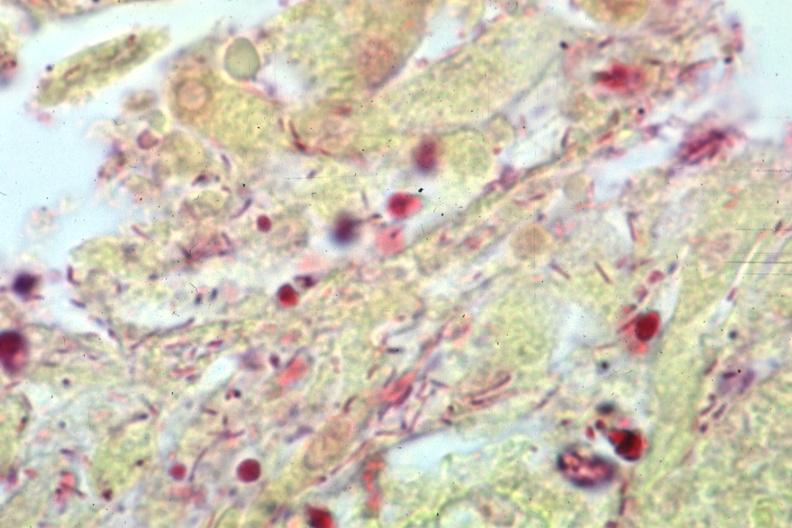what is present?
Answer the question using a single word or phrase. Brain 